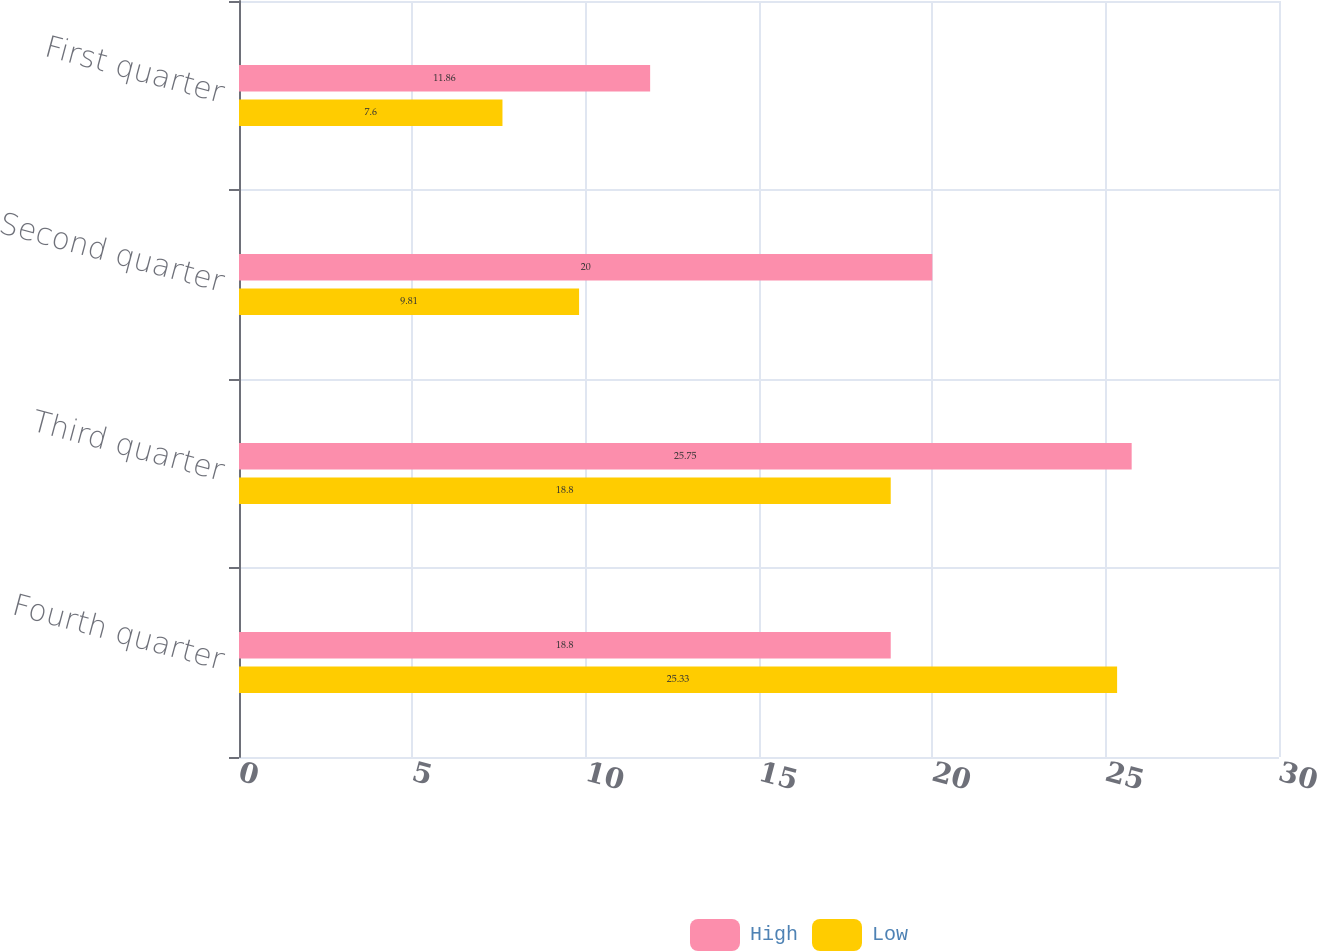Convert chart to OTSL. <chart><loc_0><loc_0><loc_500><loc_500><stacked_bar_chart><ecel><fcel>Fourth quarter<fcel>Third quarter<fcel>Second quarter<fcel>First quarter<nl><fcel>High<fcel>18.8<fcel>25.75<fcel>20<fcel>11.86<nl><fcel>Low<fcel>25.33<fcel>18.8<fcel>9.81<fcel>7.6<nl></chart> 